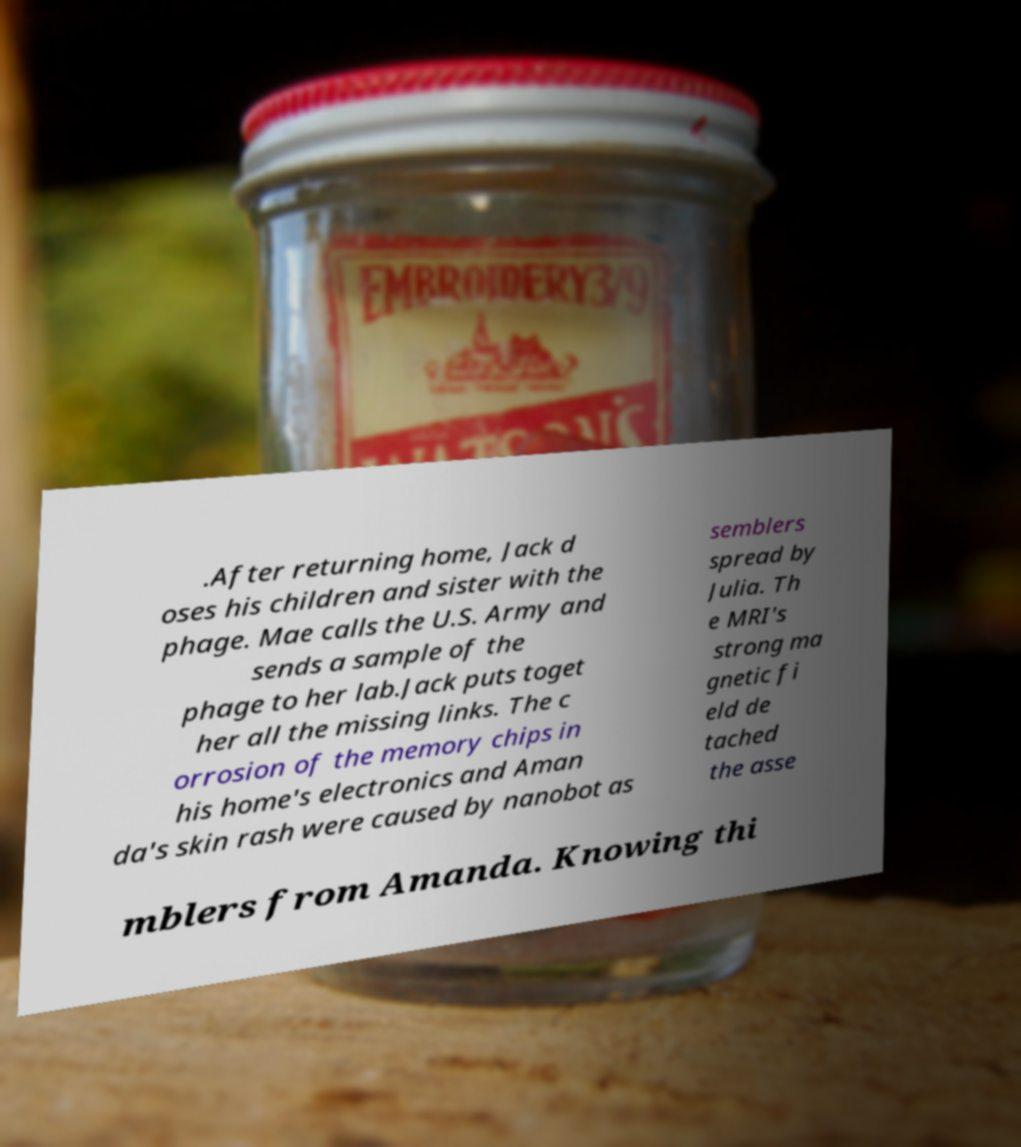Please read and relay the text visible in this image. What does it say? .After returning home, Jack d oses his children and sister with the phage. Mae calls the U.S. Army and sends a sample of the phage to her lab.Jack puts toget her all the missing links. The c orrosion of the memory chips in his home's electronics and Aman da's skin rash were caused by nanobot as semblers spread by Julia. Th e MRI's strong ma gnetic fi eld de tached the asse mblers from Amanda. Knowing thi 